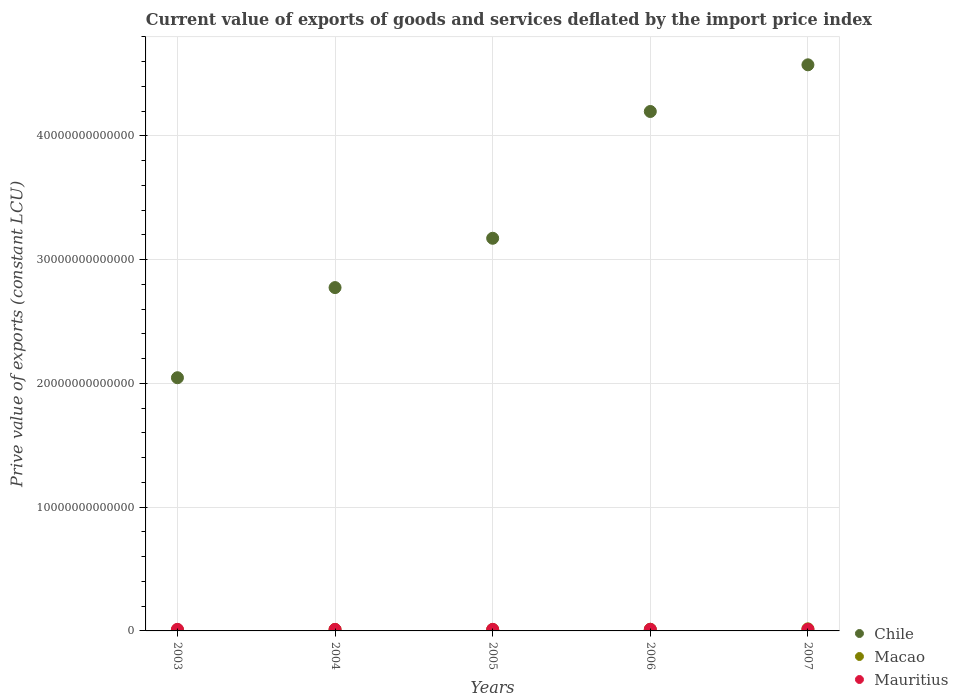Is the number of dotlines equal to the number of legend labels?
Give a very brief answer. Yes. What is the prive value of exports in Macao in 2005?
Provide a succinct answer. 1.18e+11. Across all years, what is the maximum prive value of exports in Macao?
Your response must be concise. 1.67e+11. Across all years, what is the minimum prive value of exports in Chile?
Give a very brief answer. 2.05e+13. In which year was the prive value of exports in Mauritius maximum?
Your answer should be very brief. 2007. In which year was the prive value of exports in Chile minimum?
Your answer should be very brief. 2003. What is the total prive value of exports in Mauritius in the graph?
Your response must be concise. 6.40e+11. What is the difference between the prive value of exports in Chile in 2006 and that in 2007?
Ensure brevity in your answer.  -3.77e+12. What is the difference between the prive value of exports in Chile in 2004 and the prive value of exports in Macao in 2005?
Make the answer very short. 2.76e+13. What is the average prive value of exports in Mauritius per year?
Give a very brief answer. 1.28e+11. In the year 2006, what is the difference between the prive value of exports in Macao and prive value of exports in Mauritius?
Your response must be concise. 5.20e+09. What is the ratio of the prive value of exports in Macao in 2006 to that in 2007?
Make the answer very short. 0.8. What is the difference between the highest and the second highest prive value of exports in Macao?
Your answer should be very brief. 3.29e+1. What is the difference between the highest and the lowest prive value of exports in Chile?
Your answer should be very brief. 2.53e+13. In how many years, is the prive value of exports in Mauritius greater than the average prive value of exports in Mauritius taken over all years?
Offer a terse response. 3. Is the sum of the prive value of exports in Macao in 2004 and 2007 greater than the maximum prive value of exports in Mauritius across all years?
Make the answer very short. Yes. Is it the case that in every year, the sum of the prive value of exports in Mauritius and prive value of exports in Macao  is greater than the prive value of exports in Chile?
Provide a succinct answer. No. Does the prive value of exports in Mauritius monotonically increase over the years?
Provide a succinct answer. No. Is the prive value of exports in Macao strictly greater than the prive value of exports in Chile over the years?
Offer a terse response. No. Is the prive value of exports in Macao strictly less than the prive value of exports in Chile over the years?
Make the answer very short. Yes. How many years are there in the graph?
Your answer should be very brief. 5. What is the difference between two consecutive major ticks on the Y-axis?
Give a very brief answer. 1.00e+13. Are the values on the major ticks of Y-axis written in scientific E-notation?
Your answer should be very brief. No. Does the graph contain any zero values?
Provide a short and direct response. No. What is the title of the graph?
Make the answer very short. Current value of exports of goods and services deflated by the import price index. What is the label or title of the Y-axis?
Offer a very short reply. Prive value of exports (constant LCU). What is the Prive value of exports (constant LCU) in Chile in 2003?
Offer a terse response. 2.05e+13. What is the Prive value of exports (constant LCU) in Macao in 2003?
Your response must be concise. 9.32e+1. What is the Prive value of exports (constant LCU) of Mauritius in 2003?
Make the answer very short. 1.29e+11. What is the Prive value of exports (constant LCU) in Chile in 2004?
Offer a terse response. 2.77e+13. What is the Prive value of exports (constant LCU) of Macao in 2004?
Make the answer very short. 1.20e+11. What is the Prive value of exports (constant LCU) of Mauritius in 2004?
Give a very brief answer. 1.24e+11. What is the Prive value of exports (constant LCU) of Chile in 2005?
Your response must be concise. 3.17e+13. What is the Prive value of exports (constant LCU) in Macao in 2005?
Offer a terse response. 1.18e+11. What is the Prive value of exports (constant LCU) of Mauritius in 2005?
Your response must be concise. 1.25e+11. What is the Prive value of exports (constant LCU) in Chile in 2006?
Give a very brief answer. 4.20e+13. What is the Prive value of exports (constant LCU) of Macao in 2006?
Provide a succinct answer. 1.34e+11. What is the Prive value of exports (constant LCU) of Mauritius in 2006?
Give a very brief answer. 1.29e+11. What is the Prive value of exports (constant LCU) of Chile in 2007?
Offer a very short reply. 4.57e+13. What is the Prive value of exports (constant LCU) of Macao in 2007?
Offer a very short reply. 1.67e+11. What is the Prive value of exports (constant LCU) in Mauritius in 2007?
Provide a short and direct response. 1.34e+11. Across all years, what is the maximum Prive value of exports (constant LCU) of Chile?
Offer a very short reply. 4.57e+13. Across all years, what is the maximum Prive value of exports (constant LCU) of Macao?
Provide a short and direct response. 1.67e+11. Across all years, what is the maximum Prive value of exports (constant LCU) of Mauritius?
Keep it short and to the point. 1.34e+11. Across all years, what is the minimum Prive value of exports (constant LCU) of Chile?
Offer a very short reply. 2.05e+13. Across all years, what is the minimum Prive value of exports (constant LCU) of Macao?
Your response must be concise. 9.32e+1. Across all years, what is the minimum Prive value of exports (constant LCU) of Mauritius?
Ensure brevity in your answer.  1.24e+11. What is the total Prive value of exports (constant LCU) of Chile in the graph?
Provide a short and direct response. 1.68e+14. What is the total Prive value of exports (constant LCU) of Macao in the graph?
Give a very brief answer. 6.32e+11. What is the total Prive value of exports (constant LCU) of Mauritius in the graph?
Your answer should be very brief. 6.40e+11. What is the difference between the Prive value of exports (constant LCU) of Chile in 2003 and that in 2004?
Give a very brief answer. -7.28e+12. What is the difference between the Prive value of exports (constant LCU) in Macao in 2003 and that in 2004?
Make the answer very short. -2.67e+1. What is the difference between the Prive value of exports (constant LCU) of Mauritius in 2003 and that in 2004?
Offer a very short reply. 4.84e+09. What is the difference between the Prive value of exports (constant LCU) in Chile in 2003 and that in 2005?
Make the answer very short. -1.13e+13. What is the difference between the Prive value of exports (constant LCU) of Macao in 2003 and that in 2005?
Ensure brevity in your answer.  -2.47e+1. What is the difference between the Prive value of exports (constant LCU) in Mauritius in 2003 and that in 2005?
Make the answer very short. 3.71e+09. What is the difference between the Prive value of exports (constant LCU) in Chile in 2003 and that in 2006?
Ensure brevity in your answer.  -2.15e+13. What is the difference between the Prive value of exports (constant LCU) of Macao in 2003 and that in 2006?
Provide a short and direct response. -4.10e+1. What is the difference between the Prive value of exports (constant LCU) of Mauritius in 2003 and that in 2006?
Offer a very short reply. -2.54e+08. What is the difference between the Prive value of exports (constant LCU) of Chile in 2003 and that in 2007?
Keep it short and to the point. -2.53e+13. What is the difference between the Prive value of exports (constant LCU) of Macao in 2003 and that in 2007?
Offer a very short reply. -7.39e+1. What is the difference between the Prive value of exports (constant LCU) in Mauritius in 2003 and that in 2007?
Offer a terse response. -4.97e+09. What is the difference between the Prive value of exports (constant LCU) in Chile in 2004 and that in 2005?
Your response must be concise. -3.98e+12. What is the difference between the Prive value of exports (constant LCU) in Macao in 2004 and that in 2005?
Ensure brevity in your answer.  1.95e+09. What is the difference between the Prive value of exports (constant LCU) of Mauritius in 2004 and that in 2005?
Give a very brief answer. -1.13e+09. What is the difference between the Prive value of exports (constant LCU) in Chile in 2004 and that in 2006?
Provide a succinct answer. -1.42e+13. What is the difference between the Prive value of exports (constant LCU) of Macao in 2004 and that in 2006?
Offer a terse response. -1.43e+1. What is the difference between the Prive value of exports (constant LCU) in Mauritius in 2004 and that in 2006?
Your response must be concise. -5.09e+09. What is the difference between the Prive value of exports (constant LCU) in Chile in 2004 and that in 2007?
Give a very brief answer. -1.80e+13. What is the difference between the Prive value of exports (constant LCU) of Macao in 2004 and that in 2007?
Your answer should be compact. -4.73e+1. What is the difference between the Prive value of exports (constant LCU) in Mauritius in 2004 and that in 2007?
Offer a terse response. -9.81e+09. What is the difference between the Prive value of exports (constant LCU) in Chile in 2005 and that in 2006?
Your answer should be very brief. -1.02e+13. What is the difference between the Prive value of exports (constant LCU) in Macao in 2005 and that in 2006?
Ensure brevity in your answer.  -1.63e+1. What is the difference between the Prive value of exports (constant LCU) of Mauritius in 2005 and that in 2006?
Keep it short and to the point. -3.96e+09. What is the difference between the Prive value of exports (constant LCU) of Chile in 2005 and that in 2007?
Provide a succinct answer. -1.40e+13. What is the difference between the Prive value of exports (constant LCU) of Macao in 2005 and that in 2007?
Ensure brevity in your answer.  -4.92e+1. What is the difference between the Prive value of exports (constant LCU) of Mauritius in 2005 and that in 2007?
Your response must be concise. -8.68e+09. What is the difference between the Prive value of exports (constant LCU) of Chile in 2006 and that in 2007?
Offer a very short reply. -3.77e+12. What is the difference between the Prive value of exports (constant LCU) in Macao in 2006 and that in 2007?
Provide a short and direct response. -3.29e+1. What is the difference between the Prive value of exports (constant LCU) in Mauritius in 2006 and that in 2007?
Offer a terse response. -4.72e+09. What is the difference between the Prive value of exports (constant LCU) in Chile in 2003 and the Prive value of exports (constant LCU) in Macao in 2004?
Provide a short and direct response. 2.03e+13. What is the difference between the Prive value of exports (constant LCU) in Chile in 2003 and the Prive value of exports (constant LCU) in Mauritius in 2004?
Your answer should be very brief. 2.03e+13. What is the difference between the Prive value of exports (constant LCU) in Macao in 2003 and the Prive value of exports (constant LCU) in Mauritius in 2004?
Your response must be concise. -3.07e+1. What is the difference between the Prive value of exports (constant LCU) of Chile in 2003 and the Prive value of exports (constant LCU) of Macao in 2005?
Your response must be concise. 2.03e+13. What is the difference between the Prive value of exports (constant LCU) of Chile in 2003 and the Prive value of exports (constant LCU) of Mauritius in 2005?
Provide a succinct answer. 2.03e+13. What is the difference between the Prive value of exports (constant LCU) of Macao in 2003 and the Prive value of exports (constant LCU) of Mauritius in 2005?
Provide a succinct answer. -3.18e+1. What is the difference between the Prive value of exports (constant LCU) in Chile in 2003 and the Prive value of exports (constant LCU) in Macao in 2006?
Your answer should be compact. 2.03e+13. What is the difference between the Prive value of exports (constant LCU) in Chile in 2003 and the Prive value of exports (constant LCU) in Mauritius in 2006?
Offer a very short reply. 2.03e+13. What is the difference between the Prive value of exports (constant LCU) of Macao in 2003 and the Prive value of exports (constant LCU) of Mauritius in 2006?
Provide a succinct answer. -3.58e+1. What is the difference between the Prive value of exports (constant LCU) in Chile in 2003 and the Prive value of exports (constant LCU) in Macao in 2007?
Give a very brief answer. 2.03e+13. What is the difference between the Prive value of exports (constant LCU) in Chile in 2003 and the Prive value of exports (constant LCU) in Mauritius in 2007?
Your answer should be very brief. 2.03e+13. What is the difference between the Prive value of exports (constant LCU) in Macao in 2003 and the Prive value of exports (constant LCU) in Mauritius in 2007?
Keep it short and to the point. -4.05e+1. What is the difference between the Prive value of exports (constant LCU) of Chile in 2004 and the Prive value of exports (constant LCU) of Macao in 2005?
Your answer should be very brief. 2.76e+13. What is the difference between the Prive value of exports (constant LCU) of Chile in 2004 and the Prive value of exports (constant LCU) of Mauritius in 2005?
Give a very brief answer. 2.76e+13. What is the difference between the Prive value of exports (constant LCU) of Macao in 2004 and the Prive value of exports (constant LCU) of Mauritius in 2005?
Provide a short and direct response. -5.17e+09. What is the difference between the Prive value of exports (constant LCU) of Chile in 2004 and the Prive value of exports (constant LCU) of Macao in 2006?
Your answer should be very brief. 2.76e+13. What is the difference between the Prive value of exports (constant LCU) in Chile in 2004 and the Prive value of exports (constant LCU) in Mauritius in 2006?
Provide a succinct answer. 2.76e+13. What is the difference between the Prive value of exports (constant LCU) of Macao in 2004 and the Prive value of exports (constant LCU) of Mauritius in 2006?
Offer a very short reply. -9.13e+09. What is the difference between the Prive value of exports (constant LCU) of Chile in 2004 and the Prive value of exports (constant LCU) of Macao in 2007?
Your answer should be very brief. 2.76e+13. What is the difference between the Prive value of exports (constant LCU) of Chile in 2004 and the Prive value of exports (constant LCU) of Mauritius in 2007?
Ensure brevity in your answer.  2.76e+13. What is the difference between the Prive value of exports (constant LCU) of Macao in 2004 and the Prive value of exports (constant LCU) of Mauritius in 2007?
Your response must be concise. -1.39e+1. What is the difference between the Prive value of exports (constant LCU) of Chile in 2005 and the Prive value of exports (constant LCU) of Macao in 2006?
Your answer should be compact. 3.16e+13. What is the difference between the Prive value of exports (constant LCU) of Chile in 2005 and the Prive value of exports (constant LCU) of Mauritius in 2006?
Give a very brief answer. 3.16e+13. What is the difference between the Prive value of exports (constant LCU) in Macao in 2005 and the Prive value of exports (constant LCU) in Mauritius in 2006?
Make the answer very short. -1.11e+1. What is the difference between the Prive value of exports (constant LCU) in Chile in 2005 and the Prive value of exports (constant LCU) in Macao in 2007?
Offer a terse response. 3.16e+13. What is the difference between the Prive value of exports (constant LCU) in Chile in 2005 and the Prive value of exports (constant LCU) in Mauritius in 2007?
Make the answer very short. 3.16e+13. What is the difference between the Prive value of exports (constant LCU) of Macao in 2005 and the Prive value of exports (constant LCU) of Mauritius in 2007?
Your answer should be very brief. -1.58e+1. What is the difference between the Prive value of exports (constant LCU) in Chile in 2006 and the Prive value of exports (constant LCU) in Macao in 2007?
Provide a succinct answer. 4.18e+13. What is the difference between the Prive value of exports (constant LCU) of Chile in 2006 and the Prive value of exports (constant LCU) of Mauritius in 2007?
Offer a very short reply. 4.18e+13. What is the difference between the Prive value of exports (constant LCU) in Macao in 2006 and the Prive value of exports (constant LCU) in Mauritius in 2007?
Your response must be concise. 4.84e+08. What is the average Prive value of exports (constant LCU) in Chile per year?
Ensure brevity in your answer.  3.35e+13. What is the average Prive value of exports (constant LCU) of Macao per year?
Offer a very short reply. 1.26e+11. What is the average Prive value of exports (constant LCU) of Mauritius per year?
Ensure brevity in your answer.  1.28e+11. In the year 2003, what is the difference between the Prive value of exports (constant LCU) in Chile and Prive value of exports (constant LCU) in Macao?
Provide a succinct answer. 2.04e+13. In the year 2003, what is the difference between the Prive value of exports (constant LCU) in Chile and Prive value of exports (constant LCU) in Mauritius?
Provide a succinct answer. 2.03e+13. In the year 2003, what is the difference between the Prive value of exports (constant LCU) in Macao and Prive value of exports (constant LCU) in Mauritius?
Offer a terse response. -3.55e+1. In the year 2004, what is the difference between the Prive value of exports (constant LCU) of Chile and Prive value of exports (constant LCU) of Macao?
Your answer should be very brief. 2.76e+13. In the year 2004, what is the difference between the Prive value of exports (constant LCU) of Chile and Prive value of exports (constant LCU) of Mauritius?
Make the answer very short. 2.76e+13. In the year 2004, what is the difference between the Prive value of exports (constant LCU) in Macao and Prive value of exports (constant LCU) in Mauritius?
Make the answer very short. -4.04e+09. In the year 2005, what is the difference between the Prive value of exports (constant LCU) in Chile and Prive value of exports (constant LCU) in Macao?
Your response must be concise. 3.16e+13. In the year 2005, what is the difference between the Prive value of exports (constant LCU) of Chile and Prive value of exports (constant LCU) of Mauritius?
Provide a succinct answer. 3.16e+13. In the year 2005, what is the difference between the Prive value of exports (constant LCU) of Macao and Prive value of exports (constant LCU) of Mauritius?
Provide a short and direct response. -7.12e+09. In the year 2006, what is the difference between the Prive value of exports (constant LCU) of Chile and Prive value of exports (constant LCU) of Macao?
Your response must be concise. 4.18e+13. In the year 2006, what is the difference between the Prive value of exports (constant LCU) in Chile and Prive value of exports (constant LCU) in Mauritius?
Provide a succinct answer. 4.18e+13. In the year 2006, what is the difference between the Prive value of exports (constant LCU) in Macao and Prive value of exports (constant LCU) in Mauritius?
Ensure brevity in your answer.  5.20e+09. In the year 2007, what is the difference between the Prive value of exports (constant LCU) of Chile and Prive value of exports (constant LCU) of Macao?
Provide a short and direct response. 4.56e+13. In the year 2007, what is the difference between the Prive value of exports (constant LCU) in Chile and Prive value of exports (constant LCU) in Mauritius?
Your answer should be compact. 4.56e+13. In the year 2007, what is the difference between the Prive value of exports (constant LCU) in Macao and Prive value of exports (constant LCU) in Mauritius?
Your answer should be very brief. 3.34e+1. What is the ratio of the Prive value of exports (constant LCU) of Chile in 2003 to that in 2004?
Give a very brief answer. 0.74. What is the ratio of the Prive value of exports (constant LCU) in Macao in 2003 to that in 2004?
Provide a succinct answer. 0.78. What is the ratio of the Prive value of exports (constant LCU) in Mauritius in 2003 to that in 2004?
Make the answer very short. 1.04. What is the ratio of the Prive value of exports (constant LCU) of Chile in 2003 to that in 2005?
Your answer should be compact. 0.64. What is the ratio of the Prive value of exports (constant LCU) of Macao in 2003 to that in 2005?
Your answer should be compact. 0.79. What is the ratio of the Prive value of exports (constant LCU) in Mauritius in 2003 to that in 2005?
Your answer should be compact. 1.03. What is the ratio of the Prive value of exports (constant LCU) in Chile in 2003 to that in 2006?
Offer a very short reply. 0.49. What is the ratio of the Prive value of exports (constant LCU) of Macao in 2003 to that in 2006?
Provide a short and direct response. 0.69. What is the ratio of the Prive value of exports (constant LCU) in Mauritius in 2003 to that in 2006?
Your response must be concise. 1. What is the ratio of the Prive value of exports (constant LCU) in Chile in 2003 to that in 2007?
Ensure brevity in your answer.  0.45. What is the ratio of the Prive value of exports (constant LCU) of Macao in 2003 to that in 2007?
Provide a succinct answer. 0.56. What is the ratio of the Prive value of exports (constant LCU) in Mauritius in 2003 to that in 2007?
Offer a terse response. 0.96. What is the ratio of the Prive value of exports (constant LCU) in Chile in 2004 to that in 2005?
Give a very brief answer. 0.87. What is the ratio of the Prive value of exports (constant LCU) in Macao in 2004 to that in 2005?
Your answer should be compact. 1.02. What is the ratio of the Prive value of exports (constant LCU) in Mauritius in 2004 to that in 2005?
Keep it short and to the point. 0.99. What is the ratio of the Prive value of exports (constant LCU) in Chile in 2004 to that in 2006?
Provide a short and direct response. 0.66. What is the ratio of the Prive value of exports (constant LCU) in Macao in 2004 to that in 2006?
Your answer should be compact. 0.89. What is the ratio of the Prive value of exports (constant LCU) of Mauritius in 2004 to that in 2006?
Provide a succinct answer. 0.96. What is the ratio of the Prive value of exports (constant LCU) of Chile in 2004 to that in 2007?
Make the answer very short. 0.61. What is the ratio of the Prive value of exports (constant LCU) in Macao in 2004 to that in 2007?
Make the answer very short. 0.72. What is the ratio of the Prive value of exports (constant LCU) of Mauritius in 2004 to that in 2007?
Offer a terse response. 0.93. What is the ratio of the Prive value of exports (constant LCU) in Chile in 2005 to that in 2006?
Your answer should be very brief. 0.76. What is the ratio of the Prive value of exports (constant LCU) of Macao in 2005 to that in 2006?
Your response must be concise. 0.88. What is the ratio of the Prive value of exports (constant LCU) in Mauritius in 2005 to that in 2006?
Provide a short and direct response. 0.97. What is the ratio of the Prive value of exports (constant LCU) of Chile in 2005 to that in 2007?
Provide a succinct answer. 0.69. What is the ratio of the Prive value of exports (constant LCU) in Macao in 2005 to that in 2007?
Provide a short and direct response. 0.71. What is the ratio of the Prive value of exports (constant LCU) of Mauritius in 2005 to that in 2007?
Give a very brief answer. 0.94. What is the ratio of the Prive value of exports (constant LCU) in Chile in 2006 to that in 2007?
Your response must be concise. 0.92. What is the ratio of the Prive value of exports (constant LCU) in Macao in 2006 to that in 2007?
Ensure brevity in your answer.  0.8. What is the ratio of the Prive value of exports (constant LCU) of Mauritius in 2006 to that in 2007?
Offer a terse response. 0.96. What is the difference between the highest and the second highest Prive value of exports (constant LCU) of Chile?
Keep it short and to the point. 3.77e+12. What is the difference between the highest and the second highest Prive value of exports (constant LCU) of Macao?
Provide a succinct answer. 3.29e+1. What is the difference between the highest and the second highest Prive value of exports (constant LCU) in Mauritius?
Give a very brief answer. 4.72e+09. What is the difference between the highest and the lowest Prive value of exports (constant LCU) in Chile?
Make the answer very short. 2.53e+13. What is the difference between the highest and the lowest Prive value of exports (constant LCU) in Macao?
Offer a very short reply. 7.39e+1. What is the difference between the highest and the lowest Prive value of exports (constant LCU) of Mauritius?
Provide a succinct answer. 9.81e+09. 